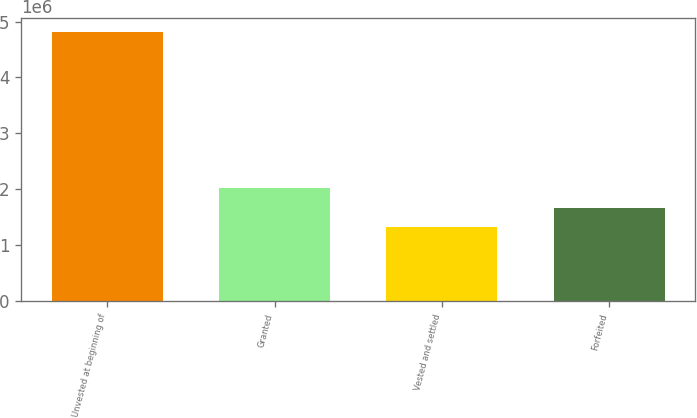Convert chart to OTSL. <chart><loc_0><loc_0><loc_500><loc_500><bar_chart><fcel>Unvested at beginning of<fcel>Granted<fcel>Vested and settled<fcel>Forfeited<nl><fcel>4.81686e+06<fcel>2.01651e+06<fcel>1.31643e+06<fcel>1.66647e+06<nl></chart> 